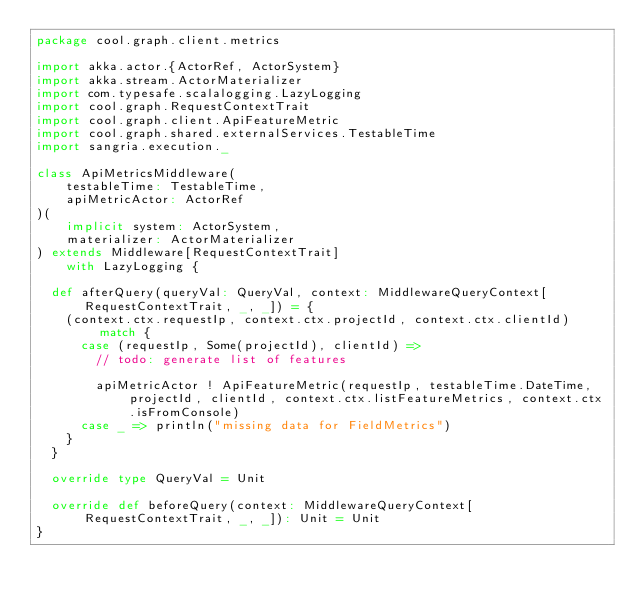<code> <loc_0><loc_0><loc_500><loc_500><_Scala_>package cool.graph.client.metrics

import akka.actor.{ActorRef, ActorSystem}
import akka.stream.ActorMaterializer
import com.typesafe.scalalogging.LazyLogging
import cool.graph.RequestContextTrait
import cool.graph.client.ApiFeatureMetric
import cool.graph.shared.externalServices.TestableTime
import sangria.execution._

class ApiMetricsMiddleware(
    testableTime: TestableTime,
    apiMetricActor: ActorRef
)(
    implicit system: ActorSystem,
    materializer: ActorMaterializer
) extends Middleware[RequestContextTrait]
    with LazyLogging {

  def afterQuery(queryVal: QueryVal, context: MiddlewareQueryContext[RequestContextTrait, _, _]) = {
    (context.ctx.requestIp, context.ctx.projectId, context.ctx.clientId) match {
      case (requestIp, Some(projectId), clientId) =>
        // todo: generate list of features

        apiMetricActor ! ApiFeatureMetric(requestIp, testableTime.DateTime, projectId, clientId, context.ctx.listFeatureMetrics, context.ctx.isFromConsole)
      case _ => println("missing data for FieldMetrics")
    }
  }

  override type QueryVal = Unit

  override def beforeQuery(context: MiddlewareQueryContext[RequestContextTrait, _, _]): Unit = Unit
}
</code> 